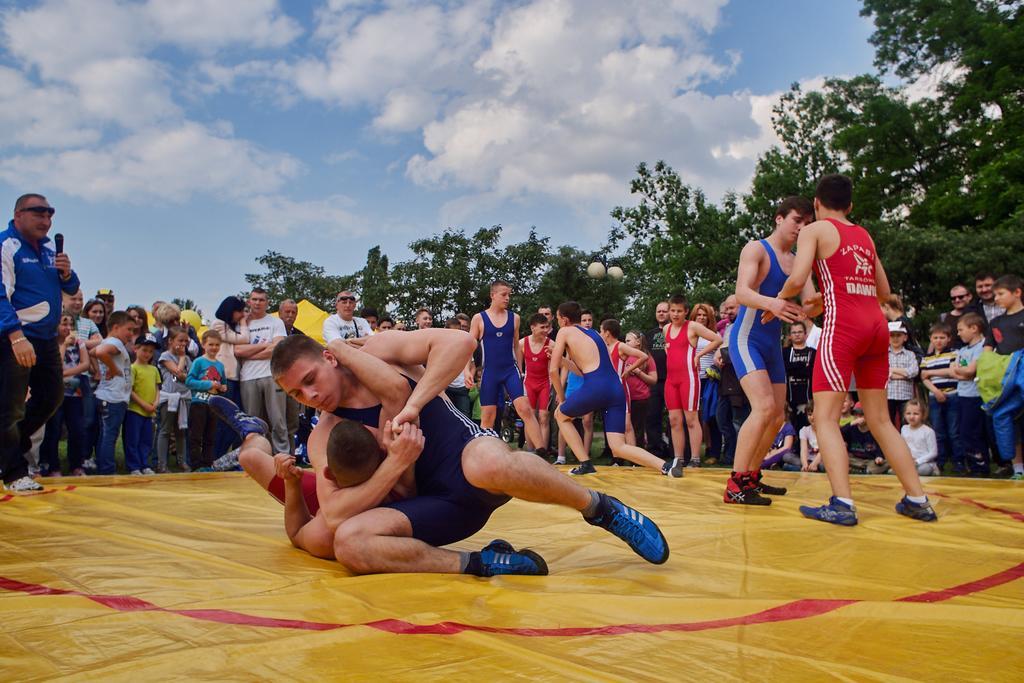How would you summarize this image in a sentence or two? In this image, we can see persons doing wrestling. There is a crowd and some persons in the middle of the image. There is a sky at the top of the image. 